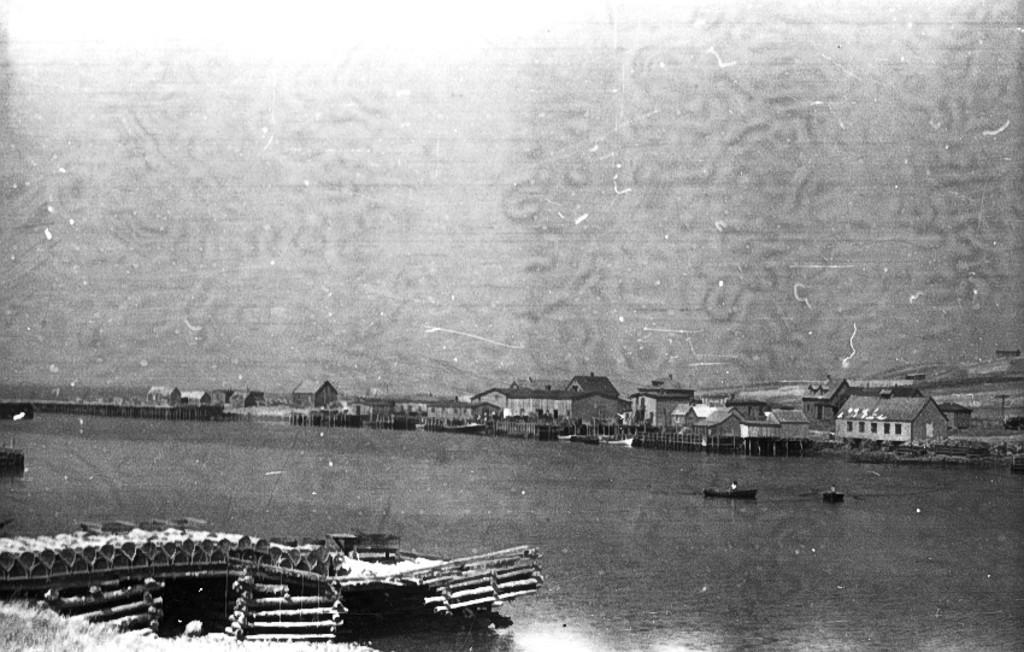What is the color scheme of the image? The image is black and white. What type of structures can be seen in the image? There are houses in the image. What type of barrier is present in the image? There is a fence in the image. What type of man-made structure is present over the water in the image? There is a wooden bridge in the image. What type of vehicles are on the water in the image? There are boats on the water in the image. What type of brass objects can be seen in the image? There are no brass objects present in the image. What type of design is featured on the clouds in the image? There are no clouds present in the image, as it is a black and white image. 